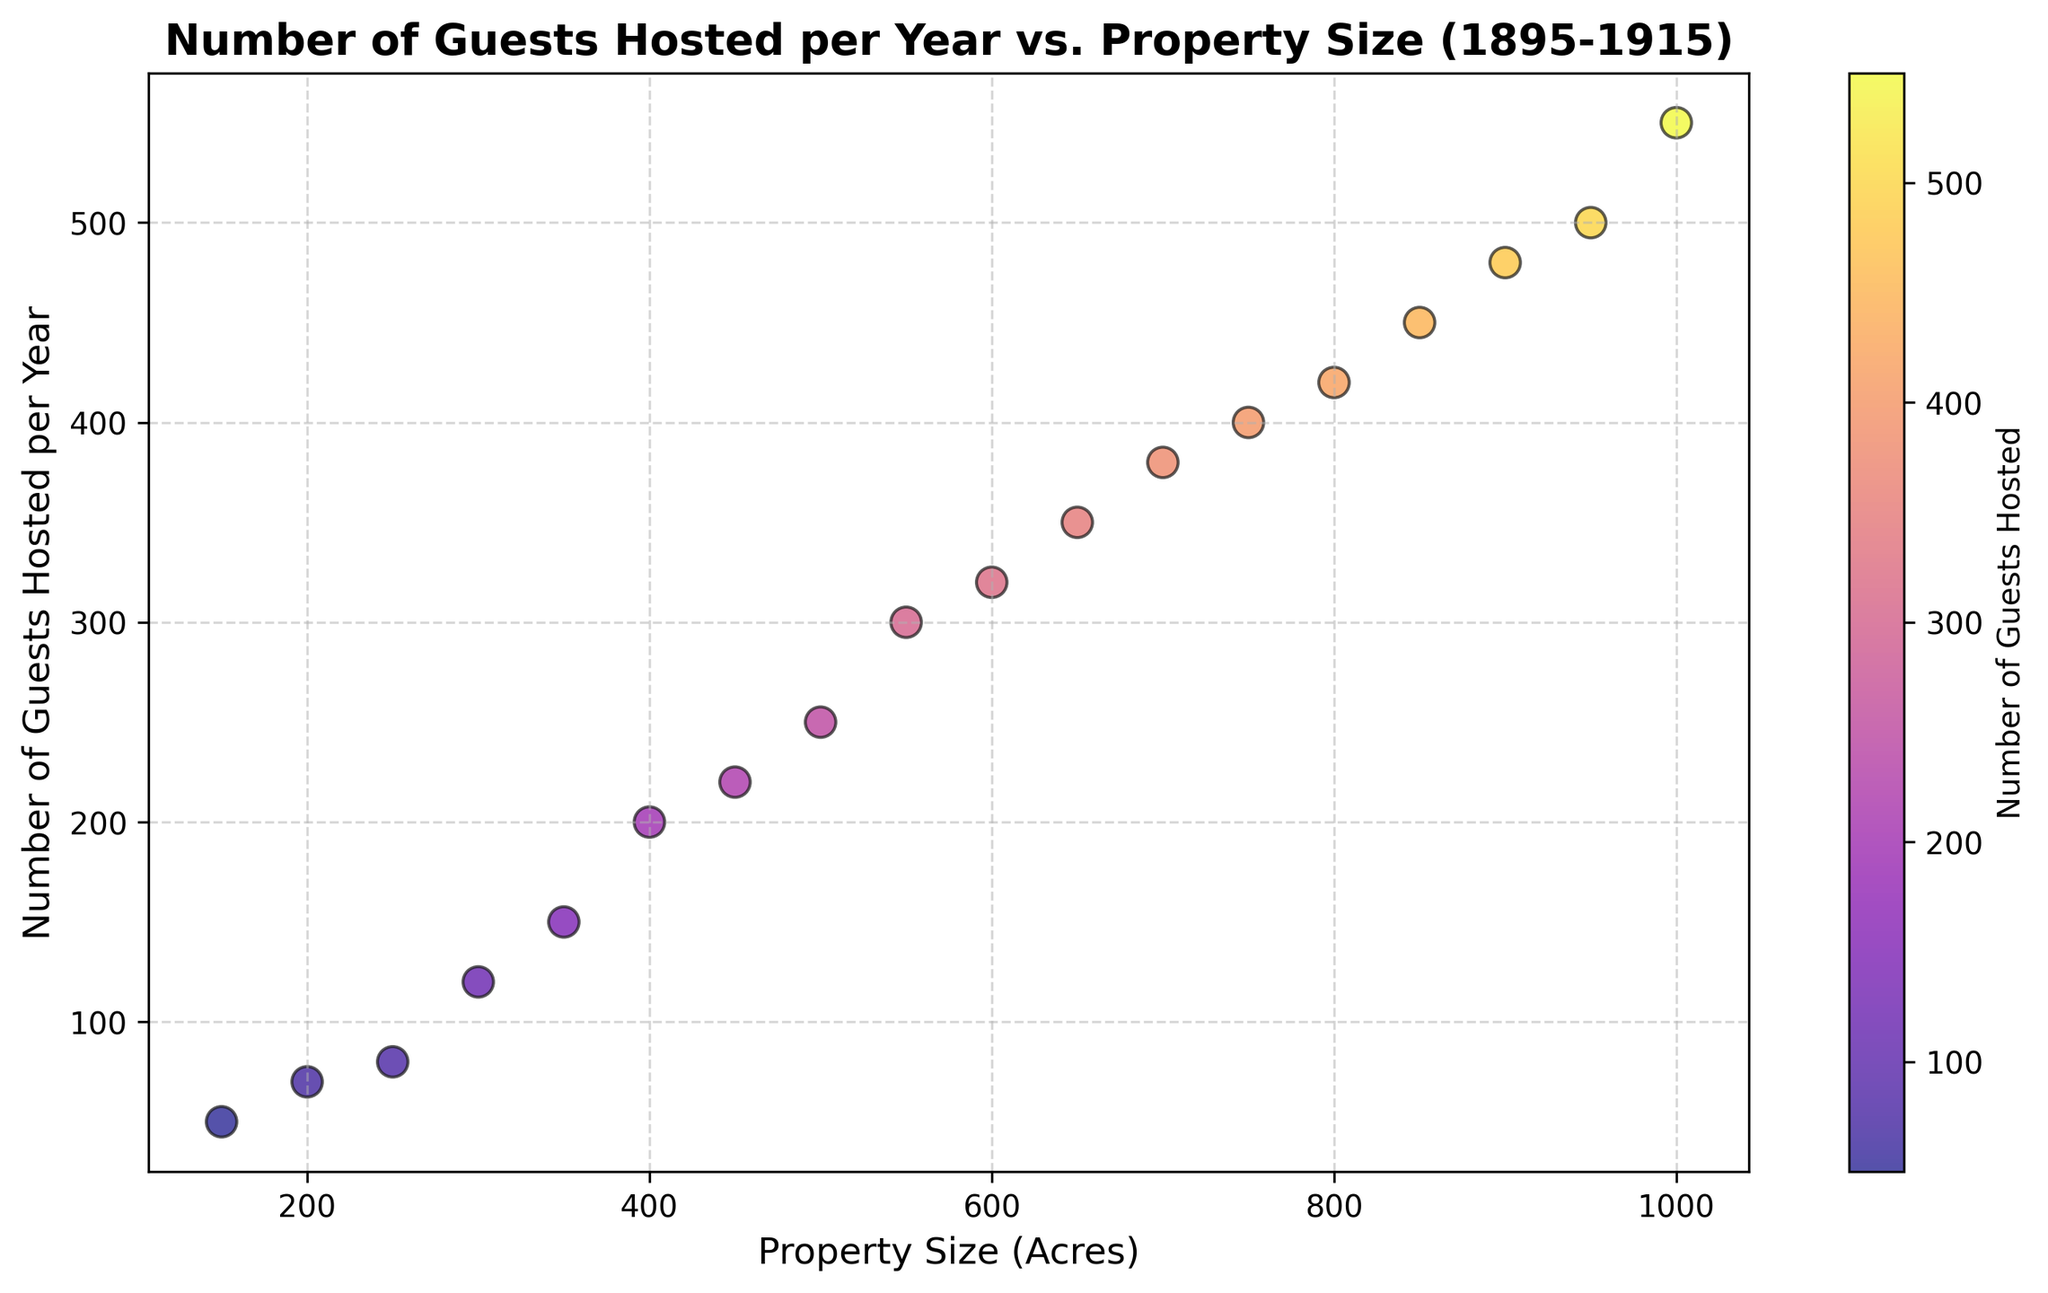1. What is the relationship between Property Size (Acres) and Number of Guests Hosted per Year? By observing the plot, as the property size increases, the number of guests hosted per year also increases. This indicates a positive correlation between property size and the number of guests hosted.
Answer: Positive correlation 2. How many guests are hosted per year by the estate with 500 acres of land? Refer to the scatter plot, find the point corresponding to 500 acres on the x-axis, and check the y-axis value for this point. The estate with 500 acres hosts approximately 250 guests per year.
Answer: 250 3. Which estate hosts more guests per year: the one with 600 acres or the one with 800 acres? Compare the y-axis values for property sizes of 600 acres and 800 acres. The estate with 600 acres hosts around 320 guests, whereas the estate with 800 acres hosts around 420 guests per year.
Answer: 800 acres 4. What can be inferred about estates smaller than 400 acres in terms of guests hosted? Look at the scatter plot points corresponding to property sizes smaller than 400 acres. All these estates host fewer than 200 guests per year.
Answer: Fewer than 200 guests 5. If an estate with 700 acres decides to increase its guest-hosting capacity by 10%, how many more guests would it host? The estate with 700 acres currently hosts 380 guests. A 10% increase means an additional 38 guests (380 * 0.10 = 38). Therefore, after the increase, it would host 380 + 38 = 418 guests.
Answer: 418 guests 6. What is the average number of guests hosted by estates larger than 900 acres? Identify the estates larger than 900 acres: those with 950 and 1000 acres, hosting 500 and 550 guests, respectively. The average is calculated as (500 + 550) / 2 = 525.
Answer: 525 7. Is there any estate that hosts exactly 300 guests per year? If so, what is its property size in acres? Check the y-axis value of 300 guests and find the corresponding x-axis value. The estate with 550 acres hosts exactly 300 guests per year.
Answer: 550 acres 8. For estates between 250 and 450 acres, what is the range of the number of guests hosted? Identify the number of guests for estates within this range: 250 acres hosts 80 guests, and 450 acres hosts 220 guests. Thus, the range is 220 - 80 = 140 guests.
Answer: 140 guests 9. What is the property size of the estate hosting 80 guests per year? Find the point on the scatter plot where the y-axis value is 80. This point corresponds to 250 acres on the x-axis.
Answer: 250 acres 10. How many more guests does the largest estate host compared to the smallest estate? The largest estate has 1000 acres hosting 550 guests, while the smallest estate has 150 acres hosting 50 guests. The difference is 550 - 50 = 500 guests.
Answer: 500 guests 